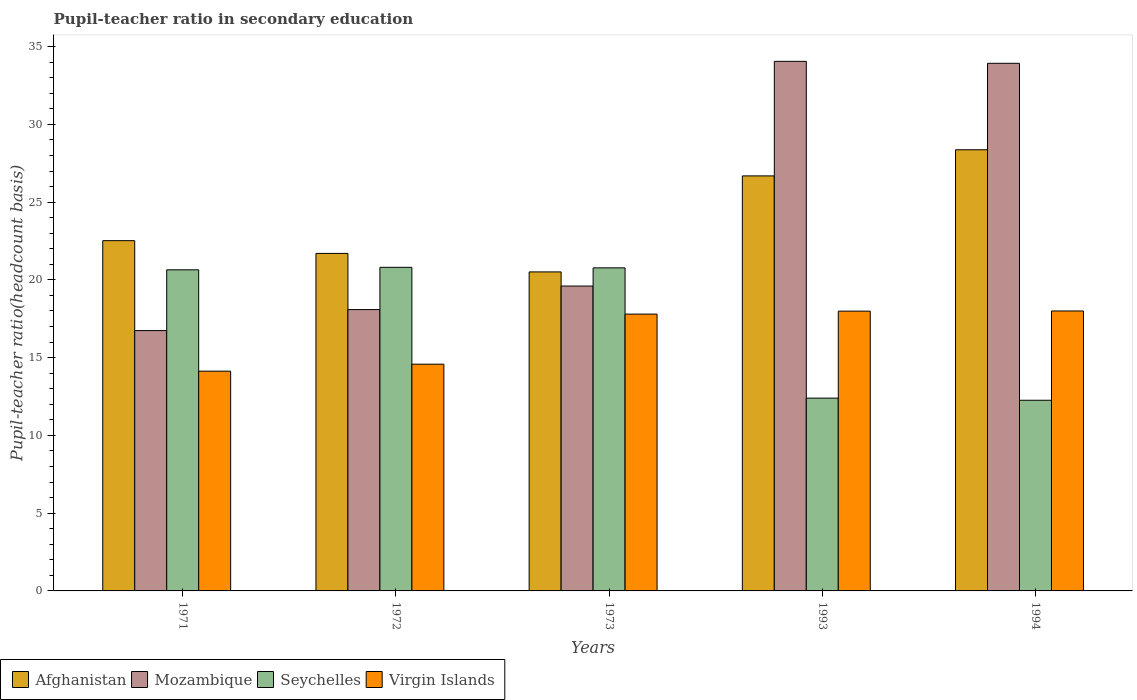How many different coloured bars are there?
Offer a very short reply. 4. How many bars are there on the 5th tick from the right?
Your answer should be very brief. 4. What is the label of the 1st group of bars from the left?
Your answer should be very brief. 1971. In how many cases, is the number of bars for a given year not equal to the number of legend labels?
Your response must be concise. 0. What is the pupil-teacher ratio in secondary education in Mozambique in 1994?
Your answer should be compact. 33.92. Across all years, what is the maximum pupil-teacher ratio in secondary education in Afghanistan?
Provide a short and direct response. 28.37. Across all years, what is the minimum pupil-teacher ratio in secondary education in Afghanistan?
Offer a terse response. 20.51. In which year was the pupil-teacher ratio in secondary education in Afghanistan minimum?
Ensure brevity in your answer.  1973. What is the total pupil-teacher ratio in secondary education in Virgin Islands in the graph?
Keep it short and to the point. 82.5. What is the difference between the pupil-teacher ratio in secondary education in Afghanistan in 1973 and that in 1994?
Provide a short and direct response. -7.85. What is the difference between the pupil-teacher ratio in secondary education in Mozambique in 1993 and the pupil-teacher ratio in secondary education in Afghanistan in 1971?
Offer a very short reply. 11.53. What is the average pupil-teacher ratio in secondary education in Seychelles per year?
Provide a short and direct response. 17.38. In the year 1994, what is the difference between the pupil-teacher ratio in secondary education in Afghanistan and pupil-teacher ratio in secondary education in Mozambique?
Give a very brief answer. -5.56. In how many years, is the pupil-teacher ratio in secondary education in Virgin Islands greater than 27?
Ensure brevity in your answer.  0. What is the ratio of the pupil-teacher ratio in secondary education in Afghanistan in 1993 to that in 1994?
Provide a succinct answer. 0.94. Is the pupil-teacher ratio in secondary education in Afghanistan in 1971 less than that in 1993?
Provide a succinct answer. Yes. Is the difference between the pupil-teacher ratio in secondary education in Afghanistan in 1971 and 1972 greater than the difference between the pupil-teacher ratio in secondary education in Mozambique in 1971 and 1972?
Your response must be concise. Yes. What is the difference between the highest and the second highest pupil-teacher ratio in secondary education in Virgin Islands?
Provide a short and direct response. 0.01. What is the difference between the highest and the lowest pupil-teacher ratio in secondary education in Mozambique?
Keep it short and to the point. 17.31. In how many years, is the pupil-teacher ratio in secondary education in Afghanistan greater than the average pupil-teacher ratio in secondary education in Afghanistan taken over all years?
Ensure brevity in your answer.  2. Is the sum of the pupil-teacher ratio in secondary education in Mozambique in 1973 and 1994 greater than the maximum pupil-teacher ratio in secondary education in Afghanistan across all years?
Ensure brevity in your answer.  Yes. What does the 3rd bar from the left in 1993 represents?
Ensure brevity in your answer.  Seychelles. What does the 1st bar from the right in 1973 represents?
Provide a short and direct response. Virgin Islands. Is it the case that in every year, the sum of the pupil-teacher ratio in secondary education in Seychelles and pupil-teacher ratio in secondary education in Afghanistan is greater than the pupil-teacher ratio in secondary education in Virgin Islands?
Provide a succinct answer. Yes. How many bars are there?
Offer a very short reply. 20. Does the graph contain any zero values?
Your response must be concise. No. Does the graph contain grids?
Give a very brief answer. No. Where does the legend appear in the graph?
Offer a terse response. Bottom left. How many legend labels are there?
Your answer should be very brief. 4. How are the legend labels stacked?
Provide a short and direct response. Horizontal. What is the title of the graph?
Offer a terse response. Pupil-teacher ratio in secondary education. Does "Antigua and Barbuda" appear as one of the legend labels in the graph?
Make the answer very short. No. What is the label or title of the Y-axis?
Your response must be concise. Pupil-teacher ratio(headcount basis). What is the Pupil-teacher ratio(headcount basis) of Afghanistan in 1971?
Provide a succinct answer. 22.52. What is the Pupil-teacher ratio(headcount basis) of Mozambique in 1971?
Provide a succinct answer. 16.74. What is the Pupil-teacher ratio(headcount basis) in Seychelles in 1971?
Your response must be concise. 20.65. What is the Pupil-teacher ratio(headcount basis) in Virgin Islands in 1971?
Ensure brevity in your answer.  14.13. What is the Pupil-teacher ratio(headcount basis) in Afghanistan in 1972?
Offer a terse response. 21.7. What is the Pupil-teacher ratio(headcount basis) in Mozambique in 1972?
Offer a terse response. 18.09. What is the Pupil-teacher ratio(headcount basis) of Seychelles in 1972?
Make the answer very short. 20.81. What is the Pupil-teacher ratio(headcount basis) of Virgin Islands in 1972?
Ensure brevity in your answer.  14.58. What is the Pupil-teacher ratio(headcount basis) of Afghanistan in 1973?
Keep it short and to the point. 20.51. What is the Pupil-teacher ratio(headcount basis) of Mozambique in 1973?
Ensure brevity in your answer.  19.6. What is the Pupil-teacher ratio(headcount basis) of Seychelles in 1973?
Provide a short and direct response. 20.77. What is the Pupil-teacher ratio(headcount basis) of Virgin Islands in 1973?
Your answer should be compact. 17.8. What is the Pupil-teacher ratio(headcount basis) in Afghanistan in 1993?
Offer a terse response. 26.68. What is the Pupil-teacher ratio(headcount basis) in Mozambique in 1993?
Your answer should be compact. 34.05. What is the Pupil-teacher ratio(headcount basis) of Seychelles in 1993?
Ensure brevity in your answer.  12.4. What is the Pupil-teacher ratio(headcount basis) of Virgin Islands in 1993?
Ensure brevity in your answer.  17.99. What is the Pupil-teacher ratio(headcount basis) in Afghanistan in 1994?
Your answer should be compact. 28.37. What is the Pupil-teacher ratio(headcount basis) of Mozambique in 1994?
Ensure brevity in your answer.  33.92. What is the Pupil-teacher ratio(headcount basis) in Seychelles in 1994?
Your answer should be compact. 12.26. Across all years, what is the maximum Pupil-teacher ratio(headcount basis) in Afghanistan?
Provide a succinct answer. 28.37. Across all years, what is the maximum Pupil-teacher ratio(headcount basis) of Mozambique?
Offer a very short reply. 34.05. Across all years, what is the maximum Pupil-teacher ratio(headcount basis) of Seychelles?
Provide a succinct answer. 20.81. Across all years, what is the minimum Pupil-teacher ratio(headcount basis) in Afghanistan?
Ensure brevity in your answer.  20.51. Across all years, what is the minimum Pupil-teacher ratio(headcount basis) in Mozambique?
Ensure brevity in your answer.  16.74. Across all years, what is the minimum Pupil-teacher ratio(headcount basis) in Seychelles?
Your answer should be compact. 12.26. Across all years, what is the minimum Pupil-teacher ratio(headcount basis) of Virgin Islands?
Keep it short and to the point. 14.13. What is the total Pupil-teacher ratio(headcount basis) in Afghanistan in the graph?
Make the answer very short. 119.78. What is the total Pupil-teacher ratio(headcount basis) of Mozambique in the graph?
Your response must be concise. 122.4. What is the total Pupil-teacher ratio(headcount basis) in Seychelles in the graph?
Your answer should be compact. 86.88. What is the total Pupil-teacher ratio(headcount basis) of Virgin Islands in the graph?
Your response must be concise. 82.5. What is the difference between the Pupil-teacher ratio(headcount basis) in Afghanistan in 1971 and that in 1972?
Your response must be concise. 0.82. What is the difference between the Pupil-teacher ratio(headcount basis) of Mozambique in 1971 and that in 1972?
Your response must be concise. -1.35. What is the difference between the Pupil-teacher ratio(headcount basis) in Seychelles in 1971 and that in 1972?
Your answer should be compact. -0.16. What is the difference between the Pupil-teacher ratio(headcount basis) in Virgin Islands in 1971 and that in 1972?
Offer a very short reply. -0.45. What is the difference between the Pupil-teacher ratio(headcount basis) of Afghanistan in 1971 and that in 1973?
Make the answer very short. 2.01. What is the difference between the Pupil-teacher ratio(headcount basis) of Mozambique in 1971 and that in 1973?
Your answer should be very brief. -2.86. What is the difference between the Pupil-teacher ratio(headcount basis) of Seychelles in 1971 and that in 1973?
Offer a terse response. -0.13. What is the difference between the Pupil-teacher ratio(headcount basis) of Virgin Islands in 1971 and that in 1973?
Provide a succinct answer. -3.67. What is the difference between the Pupil-teacher ratio(headcount basis) in Afghanistan in 1971 and that in 1993?
Offer a terse response. -4.16. What is the difference between the Pupil-teacher ratio(headcount basis) in Mozambique in 1971 and that in 1993?
Keep it short and to the point. -17.31. What is the difference between the Pupil-teacher ratio(headcount basis) of Seychelles in 1971 and that in 1993?
Your response must be concise. 8.25. What is the difference between the Pupil-teacher ratio(headcount basis) in Virgin Islands in 1971 and that in 1993?
Provide a succinct answer. -3.86. What is the difference between the Pupil-teacher ratio(headcount basis) in Afghanistan in 1971 and that in 1994?
Your answer should be very brief. -5.84. What is the difference between the Pupil-teacher ratio(headcount basis) in Mozambique in 1971 and that in 1994?
Keep it short and to the point. -17.19. What is the difference between the Pupil-teacher ratio(headcount basis) of Seychelles in 1971 and that in 1994?
Your answer should be compact. 8.39. What is the difference between the Pupil-teacher ratio(headcount basis) in Virgin Islands in 1971 and that in 1994?
Your answer should be compact. -3.87. What is the difference between the Pupil-teacher ratio(headcount basis) in Afghanistan in 1972 and that in 1973?
Your answer should be compact. 1.19. What is the difference between the Pupil-teacher ratio(headcount basis) in Mozambique in 1972 and that in 1973?
Make the answer very short. -1.51. What is the difference between the Pupil-teacher ratio(headcount basis) in Seychelles in 1972 and that in 1973?
Provide a succinct answer. 0.03. What is the difference between the Pupil-teacher ratio(headcount basis) of Virgin Islands in 1972 and that in 1973?
Ensure brevity in your answer.  -3.22. What is the difference between the Pupil-teacher ratio(headcount basis) in Afghanistan in 1972 and that in 1993?
Your answer should be very brief. -4.98. What is the difference between the Pupil-teacher ratio(headcount basis) in Mozambique in 1972 and that in 1993?
Make the answer very short. -15.96. What is the difference between the Pupil-teacher ratio(headcount basis) in Seychelles in 1972 and that in 1993?
Ensure brevity in your answer.  8.41. What is the difference between the Pupil-teacher ratio(headcount basis) of Virgin Islands in 1972 and that in 1993?
Provide a short and direct response. -3.41. What is the difference between the Pupil-teacher ratio(headcount basis) of Afghanistan in 1972 and that in 1994?
Provide a succinct answer. -6.66. What is the difference between the Pupil-teacher ratio(headcount basis) in Mozambique in 1972 and that in 1994?
Keep it short and to the point. -15.83. What is the difference between the Pupil-teacher ratio(headcount basis) of Seychelles in 1972 and that in 1994?
Ensure brevity in your answer.  8.55. What is the difference between the Pupil-teacher ratio(headcount basis) in Virgin Islands in 1972 and that in 1994?
Keep it short and to the point. -3.42. What is the difference between the Pupil-teacher ratio(headcount basis) of Afghanistan in 1973 and that in 1993?
Keep it short and to the point. -6.17. What is the difference between the Pupil-teacher ratio(headcount basis) in Mozambique in 1973 and that in 1993?
Your answer should be compact. -14.45. What is the difference between the Pupil-teacher ratio(headcount basis) in Seychelles in 1973 and that in 1993?
Offer a terse response. 8.38. What is the difference between the Pupil-teacher ratio(headcount basis) of Virgin Islands in 1973 and that in 1993?
Provide a short and direct response. -0.19. What is the difference between the Pupil-teacher ratio(headcount basis) in Afghanistan in 1973 and that in 1994?
Your answer should be very brief. -7.85. What is the difference between the Pupil-teacher ratio(headcount basis) in Mozambique in 1973 and that in 1994?
Ensure brevity in your answer.  -14.32. What is the difference between the Pupil-teacher ratio(headcount basis) of Seychelles in 1973 and that in 1994?
Ensure brevity in your answer.  8.51. What is the difference between the Pupil-teacher ratio(headcount basis) of Virgin Islands in 1973 and that in 1994?
Provide a short and direct response. -0.2. What is the difference between the Pupil-teacher ratio(headcount basis) in Afghanistan in 1993 and that in 1994?
Offer a terse response. -1.68. What is the difference between the Pupil-teacher ratio(headcount basis) of Mozambique in 1993 and that in 1994?
Make the answer very short. 0.13. What is the difference between the Pupil-teacher ratio(headcount basis) of Seychelles in 1993 and that in 1994?
Offer a very short reply. 0.14. What is the difference between the Pupil-teacher ratio(headcount basis) of Virgin Islands in 1993 and that in 1994?
Offer a terse response. -0.01. What is the difference between the Pupil-teacher ratio(headcount basis) of Afghanistan in 1971 and the Pupil-teacher ratio(headcount basis) of Mozambique in 1972?
Your answer should be very brief. 4.43. What is the difference between the Pupil-teacher ratio(headcount basis) of Afghanistan in 1971 and the Pupil-teacher ratio(headcount basis) of Seychelles in 1972?
Offer a terse response. 1.71. What is the difference between the Pupil-teacher ratio(headcount basis) of Afghanistan in 1971 and the Pupil-teacher ratio(headcount basis) of Virgin Islands in 1972?
Give a very brief answer. 7.94. What is the difference between the Pupil-teacher ratio(headcount basis) of Mozambique in 1971 and the Pupil-teacher ratio(headcount basis) of Seychelles in 1972?
Provide a short and direct response. -4.07. What is the difference between the Pupil-teacher ratio(headcount basis) of Mozambique in 1971 and the Pupil-teacher ratio(headcount basis) of Virgin Islands in 1972?
Provide a succinct answer. 2.16. What is the difference between the Pupil-teacher ratio(headcount basis) of Seychelles in 1971 and the Pupil-teacher ratio(headcount basis) of Virgin Islands in 1972?
Make the answer very short. 6.07. What is the difference between the Pupil-teacher ratio(headcount basis) in Afghanistan in 1971 and the Pupil-teacher ratio(headcount basis) in Mozambique in 1973?
Offer a very short reply. 2.92. What is the difference between the Pupil-teacher ratio(headcount basis) in Afghanistan in 1971 and the Pupil-teacher ratio(headcount basis) in Seychelles in 1973?
Your response must be concise. 1.75. What is the difference between the Pupil-teacher ratio(headcount basis) of Afghanistan in 1971 and the Pupil-teacher ratio(headcount basis) of Virgin Islands in 1973?
Provide a short and direct response. 4.72. What is the difference between the Pupil-teacher ratio(headcount basis) in Mozambique in 1971 and the Pupil-teacher ratio(headcount basis) in Seychelles in 1973?
Provide a short and direct response. -4.03. What is the difference between the Pupil-teacher ratio(headcount basis) of Mozambique in 1971 and the Pupil-teacher ratio(headcount basis) of Virgin Islands in 1973?
Offer a very short reply. -1.06. What is the difference between the Pupil-teacher ratio(headcount basis) in Seychelles in 1971 and the Pupil-teacher ratio(headcount basis) in Virgin Islands in 1973?
Your response must be concise. 2.85. What is the difference between the Pupil-teacher ratio(headcount basis) of Afghanistan in 1971 and the Pupil-teacher ratio(headcount basis) of Mozambique in 1993?
Keep it short and to the point. -11.53. What is the difference between the Pupil-teacher ratio(headcount basis) in Afghanistan in 1971 and the Pupil-teacher ratio(headcount basis) in Seychelles in 1993?
Keep it short and to the point. 10.13. What is the difference between the Pupil-teacher ratio(headcount basis) in Afghanistan in 1971 and the Pupil-teacher ratio(headcount basis) in Virgin Islands in 1993?
Make the answer very short. 4.53. What is the difference between the Pupil-teacher ratio(headcount basis) of Mozambique in 1971 and the Pupil-teacher ratio(headcount basis) of Seychelles in 1993?
Give a very brief answer. 4.34. What is the difference between the Pupil-teacher ratio(headcount basis) in Mozambique in 1971 and the Pupil-teacher ratio(headcount basis) in Virgin Islands in 1993?
Offer a very short reply. -1.25. What is the difference between the Pupil-teacher ratio(headcount basis) of Seychelles in 1971 and the Pupil-teacher ratio(headcount basis) of Virgin Islands in 1993?
Offer a terse response. 2.66. What is the difference between the Pupil-teacher ratio(headcount basis) of Afghanistan in 1971 and the Pupil-teacher ratio(headcount basis) of Mozambique in 1994?
Keep it short and to the point. -11.4. What is the difference between the Pupil-teacher ratio(headcount basis) in Afghanistan in 1971 and the Pupil-teacher ratio(headcount basis) in Seychelles in 1994?
Ensure brevity in your answer.  10.26. What is the difference between the Pupil-teacher ratio(headcount basis) in Afghanistan in 1971 and the Pupil-teacher ratio(headcount basis) in Virgin Islands in 1994?
Offer a terse response. 4.52. What is the difference between the Pupil-teacher ratio(headcount basis) of Mozambique in 1971 and the Pupil-teacher ratio(headcount basis) of Seychelles in 1994?
Your answer should be very brief. 4.48. What is the difference between the Pupil-teacher ratio(headcount basis) of Mozambique in 1971 and the Pupil-teacher ratio(headcount basis) of Virgin Islands in 1994?
Offer a very short reply. -1.26. What is the difference between the Pupil-teacher ratio(headcount basis) in Seychelles in 1971 and the Pupil-teacher ratio(headcount basis) in Virgin Islands in 1994?
Offer a terse response. 2.65. What is the difference between the Pupil-teacher ratio(headcount basis) of Afghanistan in 1972 and the Pupil-teacher ratio(headcount basis) of Mozambique in 1973?
Offer a terse response. 2.1. What is the difference between the Pupil-teacher ratio(headcount basis) of Afghanistan in 1972 and the Pupil-teacher ratio(headcount basis) of Seychelles in 1973?
Your answer should be compact. 0.93. What is the difference between the Pupil-teacher ratio(headcount basis) of Afghanistan in 1972 and the Pupil-teacher ratio(headcount basis) of Virgin Islands in 1973?
Keep it short and to the point. 3.9. What is the difference between the Pupil-teacher ratio(headcount basis) of Mozambique in 1972 and the Pupil-teacher ratio(headcount basis) of Seychelles in 1973?
Provide a succinct answer. -2.68. What is the difference between the Pupil-teacher ratio(headcount basis) of Mozambique in 1972 and the Pupil-teacher ratio(headcount basis) of Virgin Islands in 1973?
Give a very brief answer. 0.29. What is the difference between the Pupil-teacher ratio(headcount basis) of Seychelles in 1972 and the Pupil-teacher ratio(headcount basis) of Virgin Islands in 1973?
Keep it short and to the point. 3.01. What is the difference between the Pupil-teacher ratio(headcount basis) in Afghanistan in 1972 and the Pupil-teacher ratio(headcount basis) in Mozambique in 1993?
Make the answer very short. -12.35. What is the difference between the Pupil-teacher ratio(headcount basis) of Afghanistan in 1972 and the Pupil-teacher ratio(headcount basis) of Seychelles in 1993?
Provide a succinct answer. 9.31. What is the difference between the Pupil-teacher ratio(headcount basis) in Afghanistan in 1972 and the Pupil-teacher ratio(headcount basis) in Virgin Islands in 1993?
Give a very brief answer. 3.71. What is the difference between the Pupil-teacher ratio(headcount basis) of Mozambique in 1972 and the Pupil-teacher ratio(headcount basis) of Seychelles in 1993?
Make the answer very short. 5.69. What is the difference between the Pupil-teacher ratio(headcount basis) in Mozambique in 1972 and the Pupil-teacher ratio(headcount basis) in Virgin Islands in 1993?
Give a very brief answer. 0.1. What is the difference between the Pupil-teacher ratio(headcount basis) of Seychelles in 1972 and the Pupil-teacher ratio(headcount basis) of Virgin Islands in 1993?
Ensure brevity in your answer.  2.82. What is the difference between the Pupil-teacher ratio(headcount basis) in Afghanistan in 1972 and the Pupil-teacher ratio(headcount basis) in Mozambique in 1994?
Keep it short and to the point. -12.22. What is the difference between the Pupil-teacher ratio(headcount basis) in Afghanistan in 1972 and the Pupil-teacher ratio(headcount basis) in Seychelles in 1994?
Give a very brief answer. 9.44. What is the difference between the Pupil-teacher ratio(headcount basis) in Afghanistan in 1972 and the Pupil-teacher ratio(headcount basis) in Virgin Islands in 1994?
Keep it short and to the point. 3.7. What is the difference between the Pupil-teacher ratio(headcount basis) in Mozambique in 1972 and the Pupil-teacher ratio(headcount basis) in Seychelles in 1994?
Your answer should be very brief. 5.83. What is the difference between the Pupil-teacher ratio(headcount basis) in Mozambique in 1972 and the Pupil-teacher ratio(headcount basis) in Virgin Islands in 1994?
Your answer should be compact. 0.09. What is the difference between the Pupil-teacher ratio(headcount basis) of Seychelles in 1972 and the Pupil-teacher ratio(headcount basis) of Virgin Islands in 1994?
Keep it short and to the point. 2.81. What is the difference between the Pupil-teacher ratio(headcount basis) in Afghanistan in 1973 and the Pupil-teacher ratio(headcount basis) in Mozambique in 1993?
Keep it short and to the point. -13.54. What is the difference between the Pupil-teacher ratio(headcount basis) of Afghanistan in 1973 and the Pupil-teacher ratio(headcount basis) of Seychelles in 1993?
Ensure brevity in your answer.  8.12. What is the difference between the Pupil-teacher ratio(headcount basis) in Afghanistan in 1973 and the Pupil-teacher ratio(headcount basis) in Virgin Islands in 1993?
Your answer should be compact. 2.52. What is the difference between the Pupil-teacher ratio(headcount basis) in Mozambique in 1973 and the Pupil-teacher ratio(headcount basis) in Seychelles in 1993?
Your answer should be very brief. 7.21. What is the difference between the Pupil-teacher ratio(headcount basis) of Mozambique in 1973 and the Pupil-teacher ratio(headcount basis) of Virgin Islands in 1993?
Give a very brief answer. 1.61. What is the difference between the Pupil-teacher ratio(headcount basis) in Seychelles in 1973 and the Pupil-teacher ratio(headcount basis) in Virgin Islands in 1993?
Provide a short and direct response. 2.78. What is the difference between the Pupil-teacher ratio(headcount basis) in Afghanistan in 1973 and the Pupil-teacher ratio(headcount basis) in Mozambique in 1994?
Provide a short and direct response. -13.41. What is the difference between the Pupil-teacher ratio(headcount basis) of Afghanistan in 1973 and the Pupil-teacher ratio(headcount basis) of Seychelles in 1994?
Your answer should be compact. 8.25. What is the difference between the Pupil-teacher ratio(headcount basis) of Afghanistan in 1973 and the Pupil-teacher ratio(headcount basis) of Virgin Islands in 1994?
Make the answer very short. 2.51. What is the difference between the Pupil-teacher ratio(headcount basis) of Mozambique in 1973 and the Pupil-teacher ratio(headcount basis) of Seychelles in 1994?
Ensure brevity in your answer.  7.34. What is the difference between the Pupil-teacher ratio(headcount basis) of Mozambique in 1973 and the Pupil-teacher ratio(headcount basis) of Virgin Islands in 1994?
Keep it short and to the point. 1.6. What is the difference between the Pupil-teacher ratio(headcount basis) in Seychelles in 1973 and the Pupil-teacher ratio(headcount basis) in Virgin Islands in 1994?
Provide a succinct answer. 2.77. What is the difference between the Pupil-teacher ratio(headcount basis) of Afghanistan in 1993 and the Pupil-teacher ratio(headcount basis) of Mozambique in 1994?
Your answer should be very brief. -7.24. What is the difference between the Pupil-teacher ratio(headcount basis) in Afghanistan in 1993 and the Pupil-teacher ratio(headcount basis) in Seychelles in 1994?
Make the answer very short. 14.43. What is the difference between the Pupil-teacher ratio(headcount basis) of Afghanistan in 1993 and the Pupil-teacher ratio(headcount basis) of Virgin Islands in 1994?
Offer a terse response. 8.68. What is the difference between the Pupil-teacher ratio(headcount basis) in Mozambique in 1993 and the Pupil-teacher ratio(headcount basis) in Seychelles in 1994?
Give a very brief answer. 21.79. What is the difference between the Pupil-teacher ratio(headcount basis) of Mozambique in 1993 and the Pupil-teacher ratio(headcount basis) of Virgin Islands in 1994?
Offer a very short reply. 16.05. What is the difference between the Pupil-teacher ratio(headcount basis) in Seychelles in 1993 and the Pupil-teacher ratio(headcount basis) in Virgin Islands in 1994?
Your response must be concise. -5.6. What is the average Pupil-teacher ratio(headcount basis) in Afghanistan per year?
Offer a terse response. 23.96. What is the average Pupil-teacher ratio(headcount basis) of Mozambique per year?
Provide a succinct answer. 24.48. What is the average Pupil-teacher ratio(headcount basis) of Seychelles per year?
Your response must be concise. 17.38. What is the average Pupil-teacher ratio(headcount basis) in Virgin Islands per year?
Provide a short and direct response. 16.5. In the year 1971, what is the difference between the Pupil-teacher ratio(headcount basis) of Afghanistan and Pupil-teacher ratio(headcount basis) of Mozambique?
Keep it short and to the point. 5.78. In the year 1971, what is the difference between the Pupil-teacher ratio(headcount basis) of Afghanistan and Pupil-teacher ratio(headcount basis) of Seychelles?
Make the answer very short. 1.88. In the year 1971, what is the difference between the Pupil-teacher ratio(headcount basis) of Afghanistan and Pupil-teacher ratio(headcount basis) of Virgin Islands?
Your answer should be compact. 8.39. In the year 1971, what is the difference between the Pupil-teacher ratio(headcount basis) in Mozambique and Pupil-teacher ratio(headcount basis) in Seychelles?
Your response must be concise. -3.91. In the year 1971, what is the difference between the Pupil-teacher ratio(headcount basis) of Mozambique and Pupil-teacher ratio(headcount basis) of Virgin Islands?
Your response must be concise. 2.61. In the year 1971, what is the difference between the Pupil-teacher ratio(headcount basis) of Seychelles and Pupil-teacher ratio(headcount basis) of Virgin Islands?
Your answer should be compact. 6.52. In the year 1972, what is the difference between the Pupil-teacher ratio(headcount basis) of Afghanistan and Pupil-teacher ratio(headcount basis) of Mozambique?
Offer a very short reply. 3.61. In the year 1972, what is the difference between the Pupil-teacher ratio(headcount basis) in Afghanistan and Pupil-teacher ratio(headcount basis) in Seychelles?
Keep it short and to the point. 0.89. In the year 1972, what is the difference between the Pupil-teacher ratio(headcount basis) in Afghanistan and Pupil-teacher ratio(headcount basis) in Virgin Islands?
Your answer should be very brief. 7.12. In the year 1972, what is the difference between the Pupil-teacher ratio(headcount basis) of Mozambique and Pupil-teacher ratio(headcount basis) of Seychelles?
Keep it short and to the point. -2.72. In the year 1972, what is the difference between the Pupil-teacher ratio(headcount basis) of Mozambique and Pupil-teacher ratio(headcount basis) of Virgin Islands?
Provide a short and direct response. 3.51. In the year 1972, what is the difference between the Pupil-teacher ratio(headcount basis) of Seychelles and Pupil-teacher ratio(headcount basis) of Virgin Islands?
Offer a terse response. 6.23. In the year 1973, what is the difference between the Pupil-teacher ratio(headcount basis) of Afghanistan and Pupil-teacher ratio(headcount basis) of Mozambique?
Offer a very short reply. 0.91. In the year 1973, what is the difference between the Pupil-teacher ratio(headcount basis) of Afghanistan and Pupil-teacher ratio(headcount basis) of Seychelles?
Give a very brief answer. -0.26. In the year 1973, what is the difference between the Pupil-teacher ratio(headcount basis) in Afghanistan and Pupil-teacher ratio(headcount basis) in Virgin Islands?
Offer a terse response. 2.71. In the year 1973, what is the difference between the Pupil-teacher ratio(headcount basis) of Mozambique and Pupil-teacher ratio(headcount basis) of Seychelles?
Your answer should be very brief. -1.17. In the year 1973, what is the difference between the Pupil-teacher ratio(headcount basis) of Mozambique and Pupil-teacher ratio(headcount basis) of Virgin Islands?
Offer a terse response. 1.8. In the year 1973, what is the difference between the Pupil-teacher ratio(headcount basis) of Seychelles and Pupil-teacher ratio(headcount basis) of Virgin Islands?
Your answer should be very brief. 2.97. In the year 1993, what is the difference between the Pupil-teacher ratio(headcount basis) in Afghanistan and Pupil-teacher ratio(headcount basis) in Mozambique?
Ensure brevity in your answer.  -7.37. In the year 1993, what is the difference between the Pupil-teacher ratio(headcount basis) in Afghanistan and Pupil-teacher ratio(headcount basis) in Seychelles?
Give a very brief answer. 14.29. In the year 1993, what is the difference between the Pupil-teacher ratio(headcount basis) of Afghanistan and Pupil-teacher ratio(headcount basis) of Virgin Islands?
Your answer should be very brief. 8.7. In the year 1993, what is the difference between the Pupil-teacher ratio(headcount basis) in Mozambique and Pupil-teacher ratio(headcount basis) in Seychelles?
Your answer should be compact. 21.65. In the year 1993, what is the difference between the Pupil-teacher ratio(headcount basis) in Mozambique and Pupil-teacher ratio(headcount basis) in Virgin Islands?
Give a very brief answer. 16.06. In the year 1993, what is the difference between the Pupil-teacher ratio(headcount basis) in Seychelles and Pupil-teacher ratio(headcount basis) in Virgin Islands?
Give a very brief answer. -5.59. In the year 1994, what is the difference between the Pupil-teacher ratio(headcount basis) in Afghanistan and Pupil-teacher ratio(headcount basis) in Mozambique?
Provide a succinct answer. -5.56. In the year 1994, what is the difference between the Pupil-teacher ratio(headcount basis) in Afghanistan and Pupil-teacher ratio(headcount basis) in Seychelles?
Provide a short and direct response. 16.11. In the year 1994, what is the difference between the Pupil-teacher ratio(headcount basis) in Afghanistan and Pupil-teacher ratio(headcount basis) in Virgin Islands?
Give a very brief answer. 10.37. In the year 1994, what is the difference between the Pupil-teacher ratio(headcount basis) of Mozambique and Pupil-teacher ratio(headcount basis) of Seychelles?
Make the answer very short. 21.67. In the year 1994, what is the difference between the Pupil-teacher ratio(headcount basis) of Mozambique and Pupil-teacher ratio(headcount basis) of Virgin Islands?
Provide a succinct answer. 15.92. In the year 1994, what is the difference between the Pupil-teacher ratio(headcount basis) of Seychelles and Pupil-teacher ratio(headcount basis) of Virgin Islands?
Make the answer very short. -5.74. What is the ratio of the Pupil-teacher ratio(headcount basis) in Afghanistan in 1971 to that in 1972?
Provide a short and direct response. 1.04. What is the ratio of the Pupil-teacher ratio(headcount basis) of Mozambique in 1971 to that in 1972?
Provide a short and direct response. 0.93. What is the ratio of the Pupil-teacher ratio(headcount basis) of Seychelles in 1971 to that in 1972?
Your response must be concise. 0.99. What is the ratio of the Pupil-teacher ratio(headcount basis) in Virgin Islands in 1971 to that in 1972?
Keep it short and to the point. 0.97. What is the ratio of the Pupil-teacher ratio(headcount basis) of Afghanistan in 1971 to that in 1973?
Your answer should be compact. 1.1. What is the ratio of the Pupil-teacher ratio(headcount basis) of Mozambique in 1971 to that in 1973?
Ensure brevity in your answer.  0.85. What is the ratio of the Pupil-teacher ratio(headcount basis) of Virgin Islands in 1971 to that in 1973?
Keep it short and to the point. 0.79. What is the ratio of the Pupil-teacher ratio(headcount basis) in Afghanistan in 1971 to that in 1993?
Your response must be concise. 0.84. What is the ratio of the Pupil-teacher ratio(headcount basis) in Mozambique in 1971 to that in 1993?
Your answer should be very brief. 0.49. What is the ratio of the Pupil-teacher ratio(headcount basis) of Seychelles in 1971 to that in 1993?
Ensure brevity in your answer.  1.67. What is the ratio of the Pupil-teacher ratio(headcount basis) of Virgin Islands in 1971 to that in 1993?
Your answer should be compact. 0.79. What is the ratio of the Pupil-teacher ratio(headcount basis) of Afghanistan in 1971 to that in 1994?
Keep it short and to the point. 0.79. What is the ratio of the Pupil-teacher ratio(headcount basis) of Mozambique in 1971 to that in 1994?
Offer a terse response. 0.49. What is the ratio of the Pupil-teacher ratio(headcount basis) in Seychelles in 1971 to that in 1994?
Offer a terse response. 1.68. What is the ratio of the Pupil-teacher ratio(headcount basis) in Virgin Islands in 1971 to that in 1994?
Make the answer very short. 0.79. What is the ratio of the Pupil-teacher ratio(headcount basis) of Afghanistan in 1972 to that in 1973?
Offer a very short reply. 1.06. What is the ratio of the Pupil-teacher ratio(headcount basis) in Mozambique in 1972 to that in 1973?
Make the answer very short. 0.92. What is the ratio of the Pupil-teacher ratio(headcount basis) of Virgin Islands in 1972 to that in 1973?
Make the answer very short. 0.82. What is the ratio of the Pupil-teacher ratio(headcount basis) of Afghanistan in 1972 to that in 1993?
Ensure brevity in your answer.  0.81. What is the ratio of the Pupil-teacher ratio(headcount basis) of Mozambique in 1972 to that in 1993?
Offer a terse response. 0.53. What is the ratio of the Pupil-teacher ratio(headcount basis) in Seychelles in 1972 to that in 1993?
Offer a terse response. 1.68. What is the ratio of the Pupil-teacher ratio(headcount basis) of Virgin Islands in 1972 to that in 1993?
Give a very brief answer. 0.81. What is the ratio of the Pupil-teacher ratio(headcount basis) in Afghanistan in 1972 to that in 1994?
Your answer should be compact. 0.77. What is the ratio of the Pupil-teacher ratio(headcount basis) in Mozambique in 1972 to that in 1994?
Give a very brief answer. 0.53. What is the ratio of the Pupil-teacher ratio(headcount basis) in Seychelles in 1972 to that in 1994?
Offer a terse response. 1.7. What is the ratio of the Pupil-teacher ratio(headcount basis) in Virgin Islands in 1972 to that in 1994?
Give a very brief answer. 0.81. What is the ratio of the Pupil-teacher ratio(headcount basis) in Afghanistan in 1973 to that in 1993?
Offer a very short reply. 0.77. What is the ratio of the Pupil-teacher ratio(headcount basis) in Mozambique in 1973 to that in 1993?
Offer a very short reply. 0.58. What is the ratio of the Pupil-teacher ratio(headcount basis) of Seychelles in 1973 to that in 1993?
Give a very brief answer. 1.68. What is the ratio of the Pupil-teacher ratio(headcount basis) of Virgin Islands in 1973 to that in 1993?
Your answer should be compact. 0.99. What is the ratio of the Pupil-teacher ratio(headcount basis) of Afghanistan in 1973 to that in 1994?
Offer a very short reply. 0.72. What is the ratio of the Pupil-teacher ratio(headcount basis) of Mozambique in 1973 to that in 1994?
Your response must be concise. 0.58. What is the ratio of the Pupil-teacher ratio(headcount basis) in Seychelles in 1973 to that in 1994?
Your response must be concise. 1.69. What is the ratio of the Pupil-teacher ratio(headcount basis) in Virgin Islands in 1973 to that in 1994?
Your answer should be compact. 0.99. What is the ratio of the Pupil-teacher ratio(headcount basis) of Afghanistan in 1993 to that in 1994?
Keep it short and to the point. 0.94. What is the ratio of the Pupil-teacher ratio(headcount basis) of Mozambique in 1993 to that in 1994?
Your answer should be compact. 1. What is the ratio of the Pupil-teacher ratio(headcount basis) of Seychelles in 1993 to that in 1994?
Keep it short and to the point. 1.01. What is the ratio of the Pupil-teacher ratio(headcount basis) in Virgin Islands in 1993 to that in 1994?
Ensure brevity in your answer.  1. What is the difference between the highest and the second highest Pupil-teacher ratio(headcount basis) of Afghanistan?
Keep it short and to the point. 1.68. What is the difference between the highest and the second highest Pupil-teacher ratio(headcount basis) of Mozambique?
Your answer should be very brief. 0.13. What is the difference between the highest and the second highest Pupil-teacher ratio(headcount basis) in Seychelles?
Your answer should be very brief. 0.03. What is the difference between the highest and the second highest Pupil-teacher ratio(headcount basis) of Virgin Islands?
Provide a short and direct response. 0.01. What is the difference between the highest and the lowest Pupil-teacher ratio(headcount basis) in Afghanistan?
Your answer should be very brief. 7.85. What is the difference between the highest and the lowest Pupil-teacher ratio(headcount basis) in Mozambique?
Make the answer very short. 17.31. What is the difference between the highest and the lowest Pupil-teacher ratio(headcount basis) of Seychelles?
Make the answer very short. 8.55. What is the difference between the highest and the lowest Pupil-teacher ratio(headcount basis) of Virgin Islands?
Offer a very short reply. 3.87. 